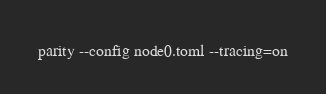Convert code to text. <code><loc_0><loc_0><loc_500><loc_500><_Bash_>parity --config node0.toml --tracing=on
</code> 